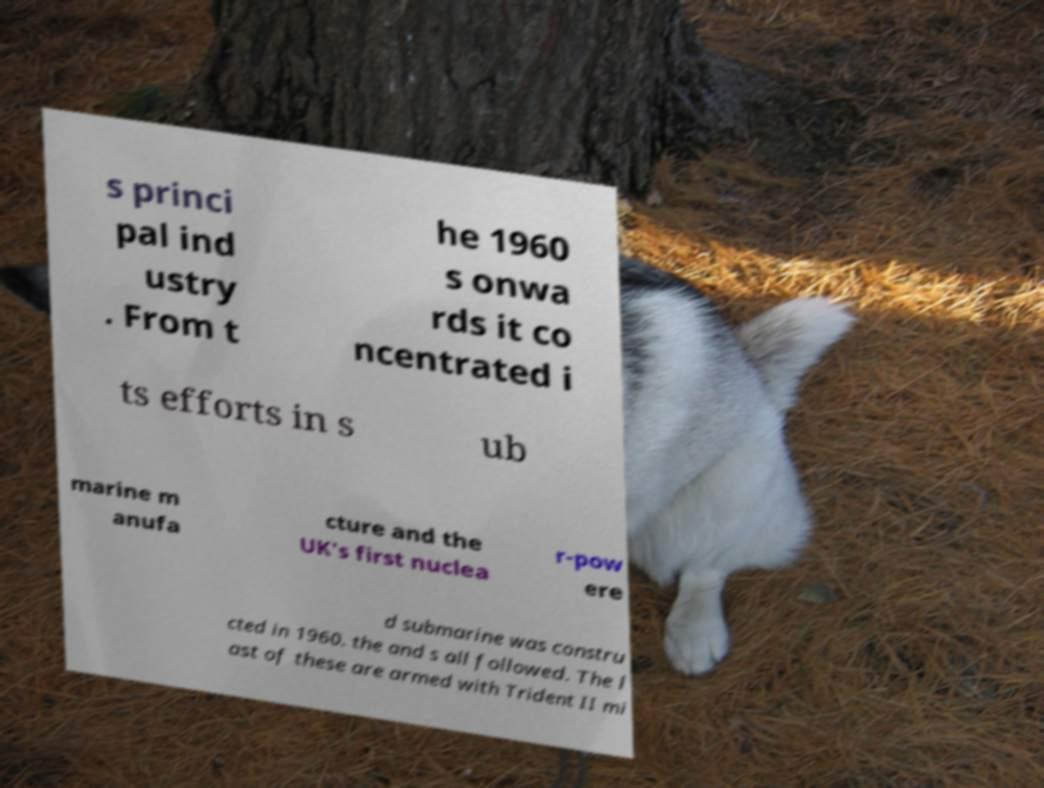I need the written content from this picture converted into text. Can you do that? s princi pal ind ustry . From t he 1960 s onwa rds it co ncentrated i ts efforts in s ub marine m anufa cture and the UK's first nuclea r-pow ere d submarine was constru cted in 1960. the and s all followed. The l ast of these are armed with Trident II mi 